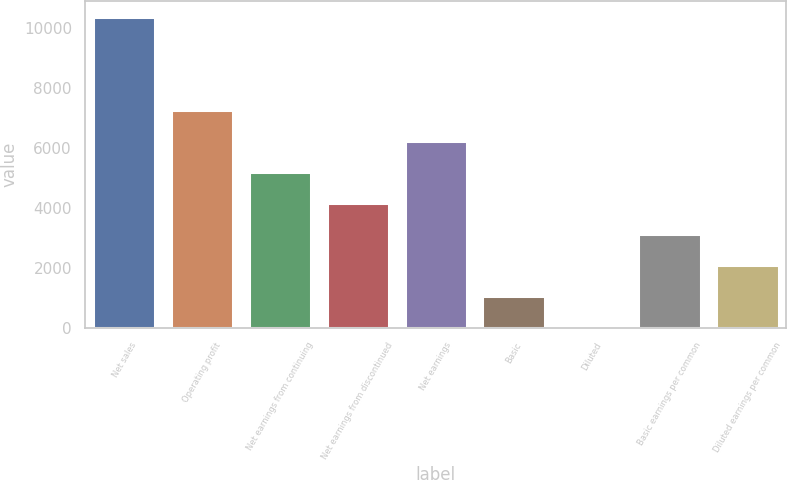<chart> <loc_0><loc_0><loc_500><loc_500><bar_chart><fcel>Net sales<fcel>Operating profit<fcel>Net earnings from continuing<fcel>Net earnings from discontinued<fcel>Net earnings<fcel>Basic<fcel>Diluted<fcel>Basic earnings per common<fcel>Diluted earnings per common<nl><fcel>10368<fcel>7258.39<fcel>5185.31<fcel>4148.77<fcel>6221.85<fcel>1039.15<fcel>2.61<fcel>3112.23<fcel>2075.69<nl></chart> 